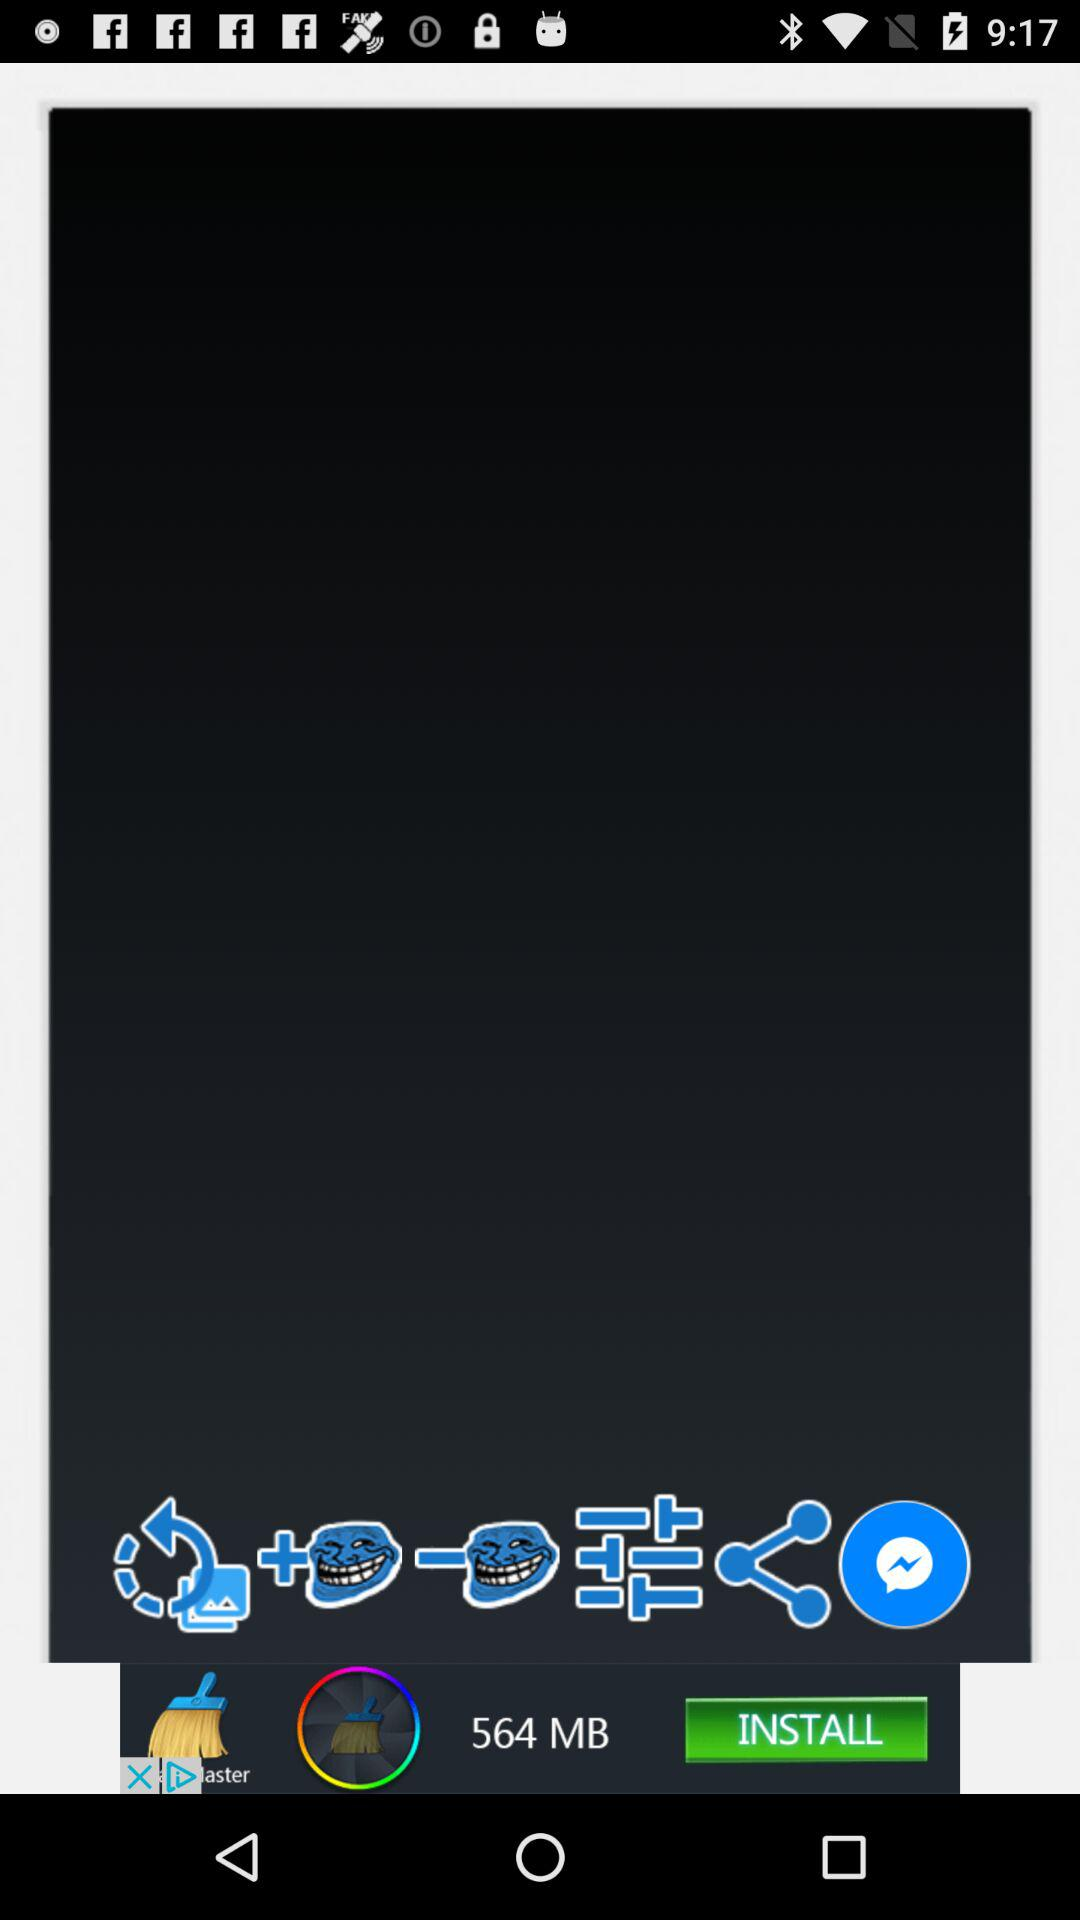How many troll faces are there on the screen?
Answer the question using a single word or phrase. 2 